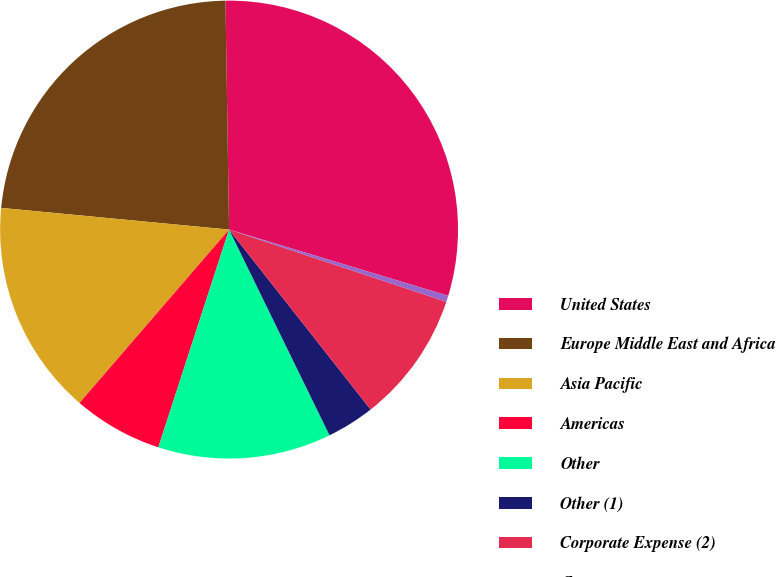Convert chart. <chart><loc_0><loc_0><loc_500><loc_500><pie_chart><fcel>United States<fcel>Europe Middle East and Africa<fcel>Asia Pacific<fcel>Americas<fcel>Other<fcel>Other (1)<fcel>Corporate Expense (2)<fcel>Corporate<nl><fcel>29.92%<fcel>23.24%<fcel>15.18%<fcel>6.33%<fcel>12.23%<fcel>3.38%<fcel>9.28%<fcel>0.44%<nl></chart> 